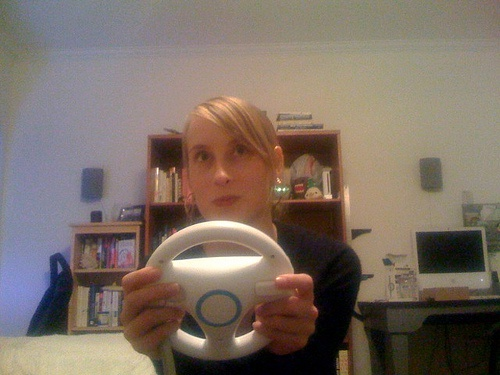Describe the objects in this image and their specific colors. I can see people in gray, black, brown, and maroon tones, remote in gray and maroon tones, couch in gray and tan tones, tv in gray and black tones, and backpack in gray, black, and navy tones in this image. 